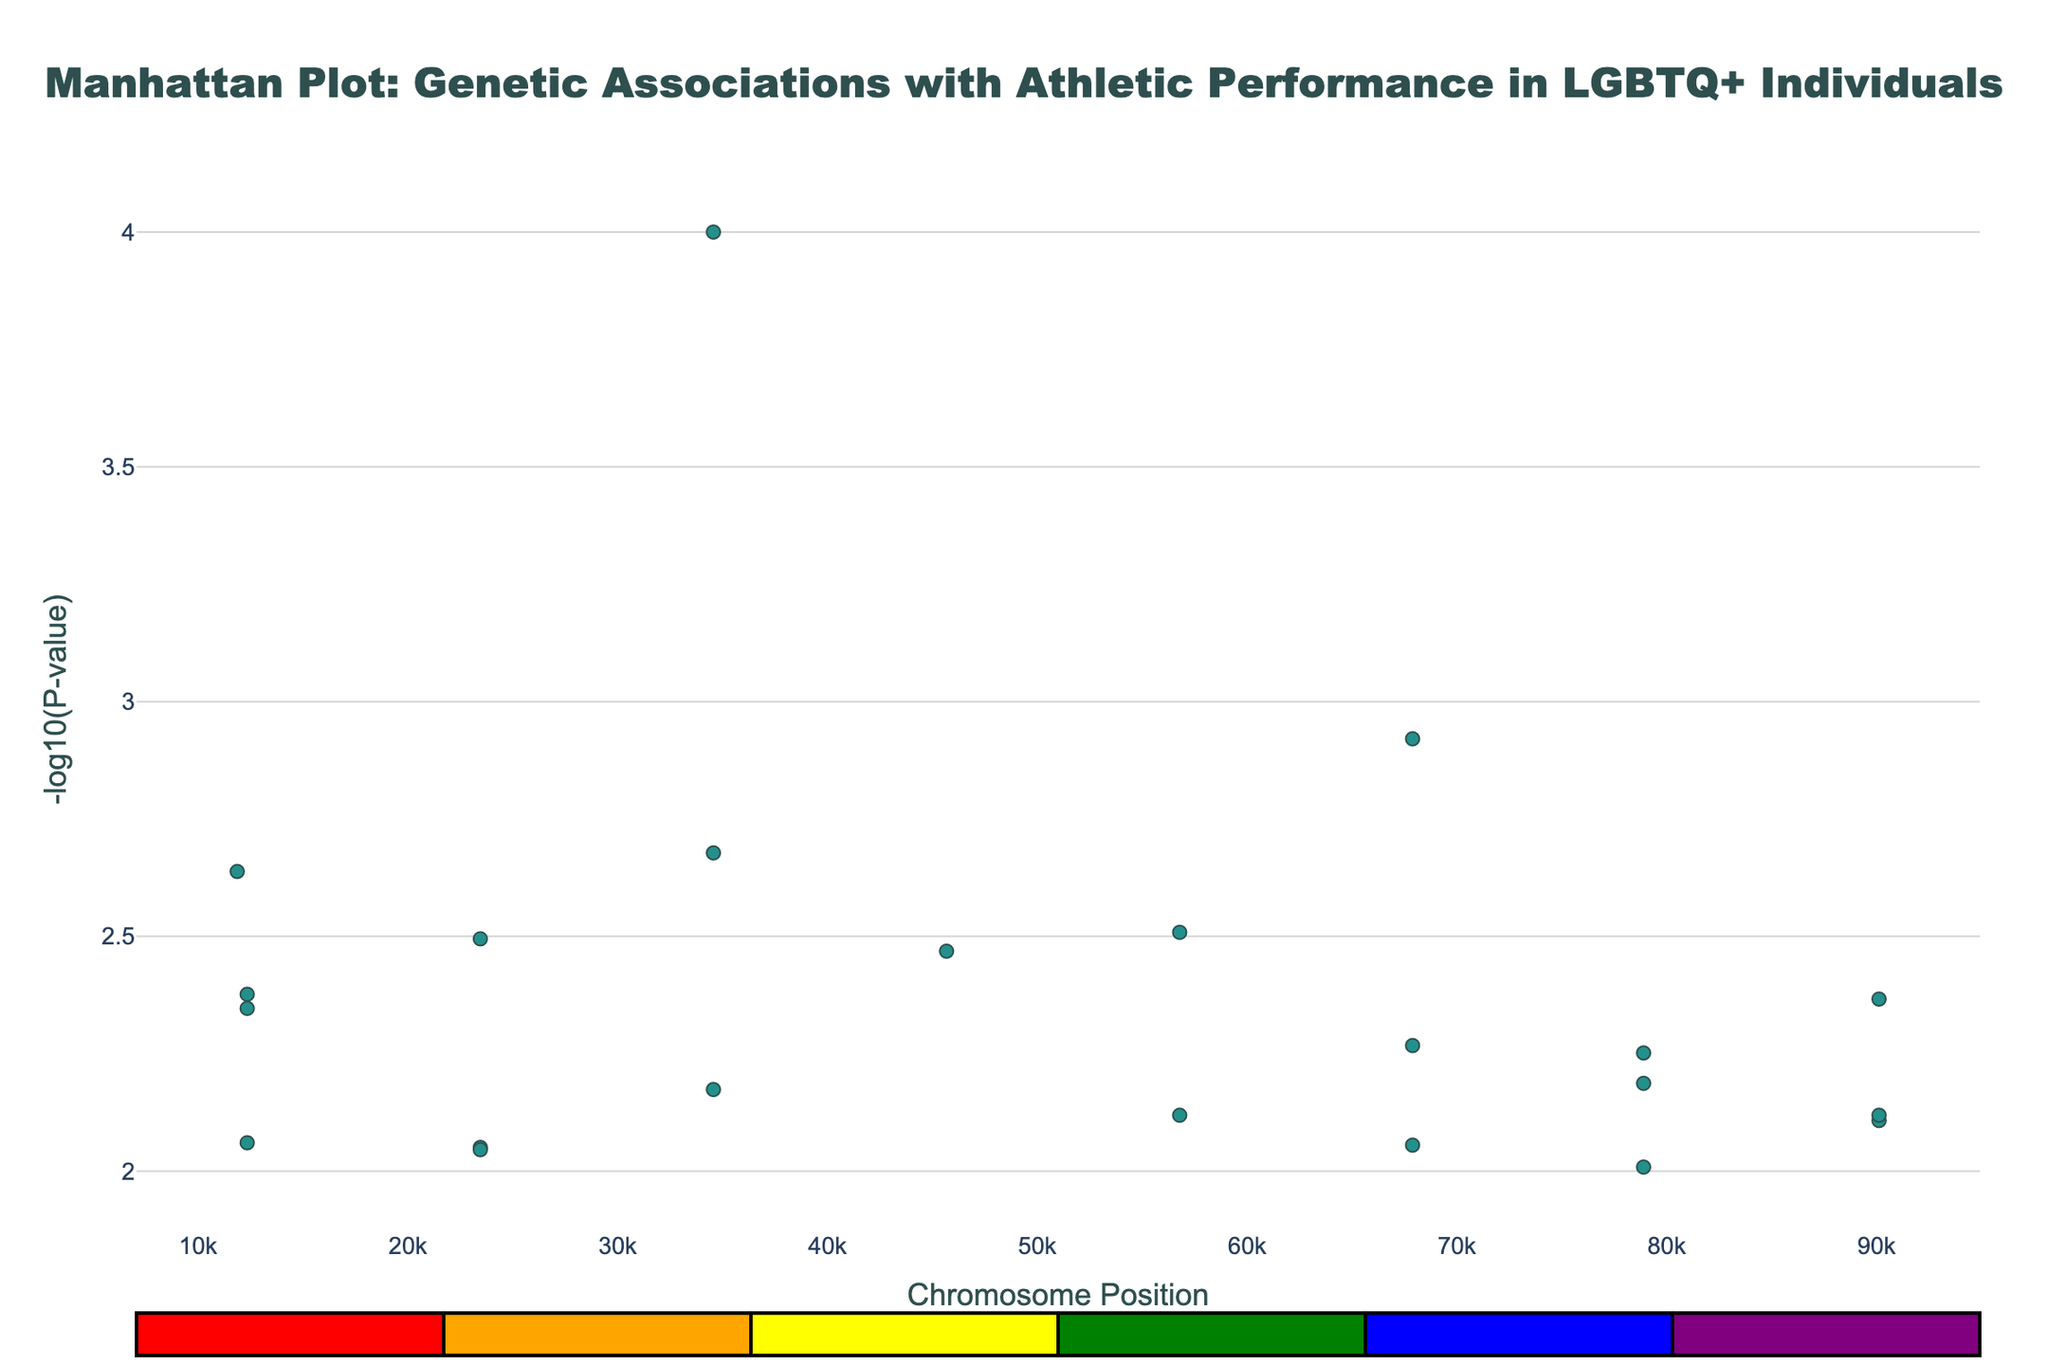How many chromosomes are represented in the plot? Count the unique chromosomes listed in the legend or in the plot's data.
Answer: 22 Which chromosome has the gene with the lowest P-value? The lowest P-value corresponds to the highest -log10(P-value) on the y-axis. Identify the highest point on the plot and look at its chromosome label.
Answer: Chromosome 2 What is the -log10(P-value) for the gene associated with reaction speed? Locate the data point for reaction speed by checking the hover text for each chromosome until the SRY gene is found. Read its y-axis value for -log10(P-value).
Answer: Approximately 2.11 Which trait is associated with the gene with the highest position on chromosome 10? Find the data point on chromosome 10 with the highest x-axis value (position). Look at the hover text to find the associated trait.
Answer: Coordination How many data points have a -log10(P-value) greater than 2? Count the number of data points whose y-values (-log10(P-value)) exceed 2.
Answer: 8 Which gene is associated with social bonding and on which chromosome is it located? Find the hover text for social bonding, then check the associated gene and chromosome.
Answer: AVPR1A, Chromosome 16 Compare the -log10(P-values) of genes associated with stress resilience and focus. Which is higher? Check the y-values of the data points for COMT (stress resilience) and DAT1 (focus). Compare their -log10(P-values).
Answer: COMT (Stress Resilience) What is the difference in chromosome positions between the genes associated with empathy and pain tolerance? Identify the x-axis positions of OXTR (empathy) and OPRM1 (pain tolerance) from the hover text on chromosome 18 and 12 respectively. Subtract the smaller position from the larger one.
Answer: 11234 What is the median -log10(P-value) for all displayed data points? List all -log10(P-values), sort them, and find the middle value. If even number of values, average the two in the middle.
Answer: Approximately 2.345 Which chromosome has more genes associated with decision-making, communication, and stress response? Determine the chromosomes associated with COMT (decision-making), FOXP2 (communication), and NR3C1 (stress response) by locating their data points. Count the frequency of each chromosome.
Answer: Chromosome 19 